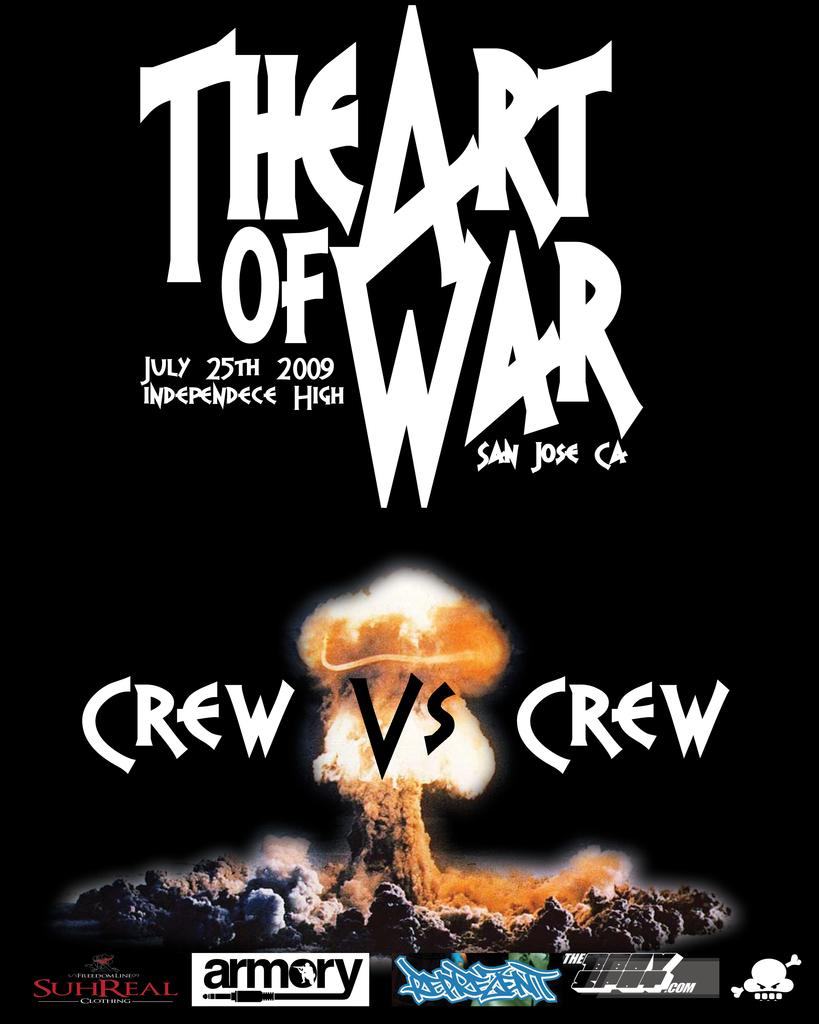<image>
Render a clear and concise summary of the photo. Poster for The Art of War which takes place on July 25th. 